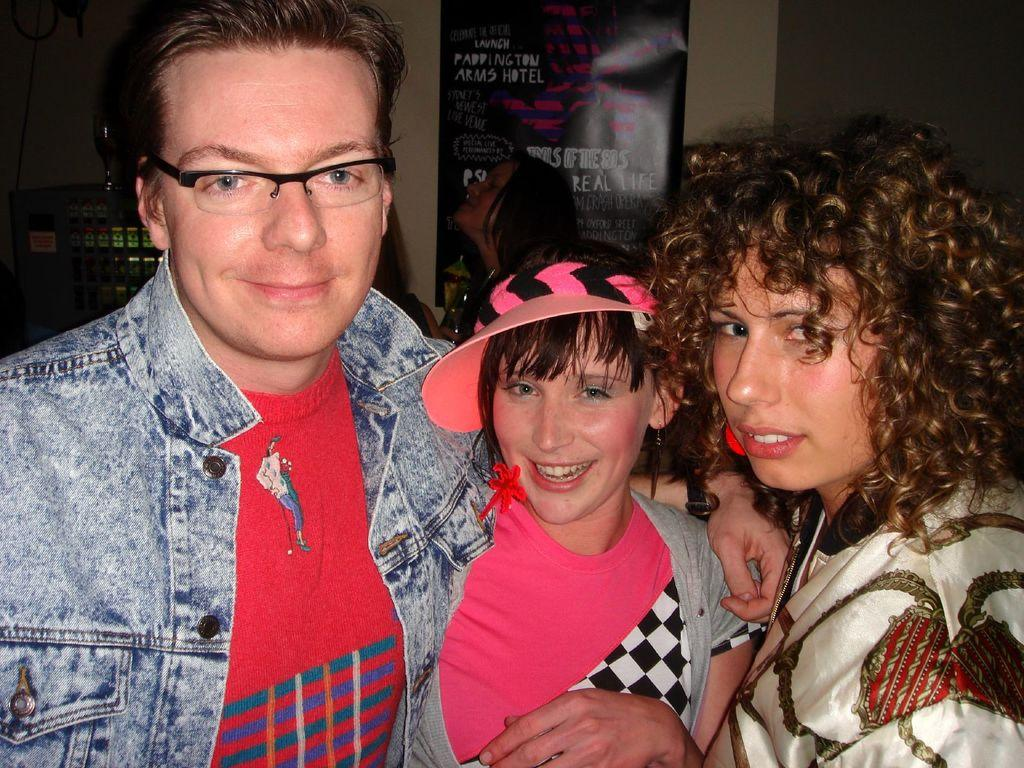How many people are in the image? There are three people in the image. What are the people doing in the image? The people are standing and posing for the camera. What expressions do the people have in the image? The people are smiling in the image. What can be seen in the background of the image? There is a poster on the wall in the background of the image. What type of skirt is the child wearing in the image? There are no children or skirts present in the image; it features three adults who are smiling and posing for the camera. How many pockets can be seen on the children's clothing in the image? There are no children or clothing with pockets present in the image. 